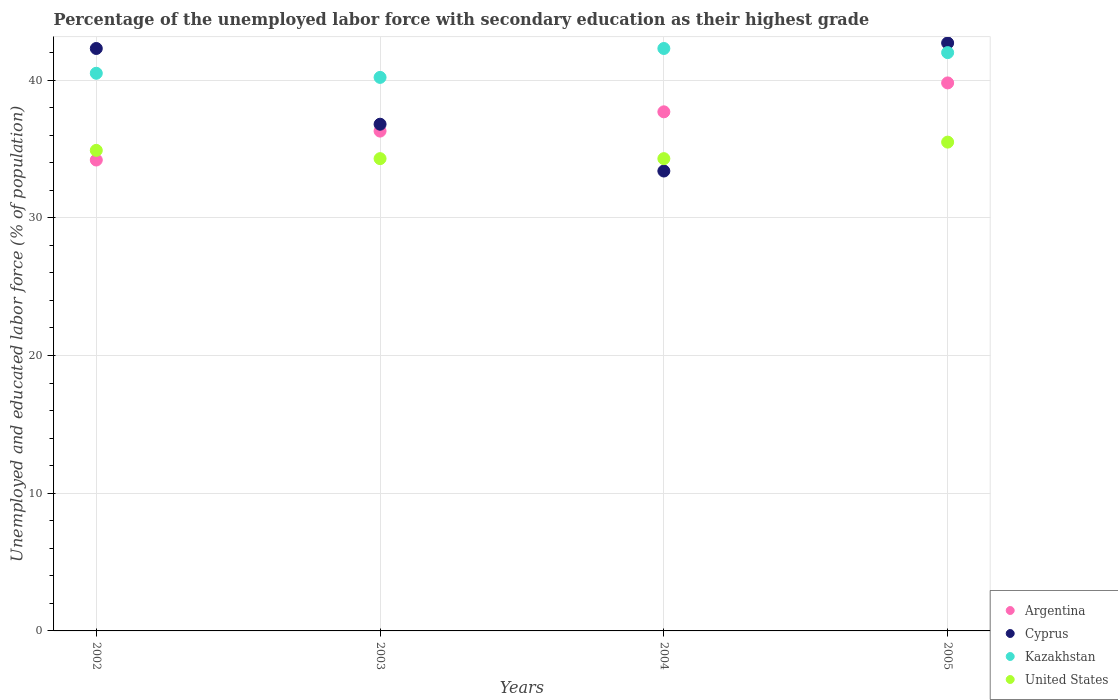Is the number of dotlines equal to the number of legend labels?
Give a very brief answer. Yes. Across all years, what is the maximum percentage of the unemployed labor force with secondary education in Cyprus?
Offer a very short reply. 42.7. Across all years, what is the minimum percentage of the unemployed labor force with secondary education in Kazakhstan?
Your response must be concise. 40.2. What is the total percentage of the unemployed labor force with secondary education in Cyprus in the graph?
Offer a terse response. 155.2. What is the difference between the percentage of the unemployed labor force with secondary education in Kazakhstan in 2003 and that in 2004?
Provide a short and direct response. -2.1. What is the average percentage of the unemployed labor force with secondary education in Cyprus per year?
Your answer should be compact. 38.8. In the year 2003, what is the difference between the percentage of the unemployed labor force with secondary education in Argentina and percentage of the unemployed labor force with secondary education in United States?
Give a very brief answer. 2. What is the ratio of the percentage of the unemployed labor force with secondary education in Kazakhstan in 2003 to that in 2005?
Provide a succinct answer. 0.96. Is the percentage of the unemployed labor force with secondary education in Cyprus in 2002 less than that in 2005?
Offer a very short reply. Yes. What is the difference between the highest and the second highest percentage of the unemployed labor force with secondary education in United States?
Provide a short and direct response. 0.6. What is the difference between the highest and the lowest percentage of the unemployed labor force with secondary education in Argentina?
Ensure brevity in your answer.  5.6. In how many years, is the percentage of the unemployed labor force with secondary education in Argentina greater than the average percentage of the unemployed labor force with secondary education in Argentina taken over all years?
Make the answer very short. 2. Is the percentage of the unemployed labor force with secondary education in Argentina strictly greater than the percentage of the unemployed labor force with secondary education in Kazakhstan over the years?
Your answer should be compact. No. How many dotlines are there?
Your answer should be compact. 4. How many years are there in the graph?
Give a very brief answer. 4. What is the difference between two consecutive major ticks on the Y-axis?
Give a very brief answer. 10. Does the graph contain any zero values?
Your response must be concise. No. What is the title of the graph?
Your answer should be compact. Percentage of the unemployed labor force with secondary education as their highest grade. Does "Fiji" appear as one of the legend labels in the graph?
Offer a terse response. No. What is the label or title of the Y-axis?
Make the answer very short. Unemployed and educated labor force (% of population). What is the Unemployed and educated labor force (% of population) of Argentina in 2002?
Your response must be concise. 34.2. What is the Unemployed and educated labor force (% of population) of Cyprus in 2002?
Provide a succinct answer. 42.3. What is the Unemployed and educated labor force (% of population) of Kazakhstan in 2002?
Offer a very short reply. 40.5. What is the Unemployed and educated labor force (% of population) of United States in 2002?
Offer a very short reply. 34.9. What is the Unemployed and educated labor force (% of population) of Argentina in 2003?
Your response must be concise. 36.3. What is the Unemployed and educated labor force (% of population) of Cyprus in 2003?
Offer a very short reply. 36.8. What is the Unemployed and educated labor force (% of population) of Kazakhstan in 2003?
Offer a terse response. 40.2. What is the Unemployed and educated labor force (% of population) of United States in 2003?
Keep it short and to the point. 34.3. What is the Unemployed and educated labor force (% of population) in Argentina in 2004?
Make the answer very short. 37.7. What is the Unemployed and educated labor force (% of population) of Cyprus in 2004?
Give a very brief answer. 33.4. What is the Unemployed and educated labor force (% of population) in Kazakhstan in 2004?
Give a very brief answer. 42.3. What is the Unemployed and educated labor force (% of population) in United States in 2004?
Provide a succinct answer. 34.3. What is the Unemployed and educated labor force (% of population) in Argentina in 2005?
Your answer should be compact. 39.8. What is the Unemployed and educated labor force (% of population) of Cyprus in 2005?
Offer a very short reply. 42.7. What is the Unemployed and educated labor force (% of population) in Kazakhstan in 2005?
Offer a terse response. 42. What is the Unemployed and educated labor force (% of population) in United States in 2005?
Your answer should be compact. 35.5. Across all years, what is the maximum Unemployed and educated labor force (% of population) of Argentina?
Give a very brief answer. 39.8. Across all years, what is the maximum Unemployed and educated labor force (% of population) in Cyprus?
Make the answer very short. 42.7. Across all years, what is the maximum Unemployed and educated labor force (% of population) of Kazakhstan?
Provide a short and direct response. 42.3. Across all years, what is the maximum Unemployed and educated labor force (% of population) of United States?
Make the answer very short. 35.5. Across all years, what is the minimum Unemployed and educated labor force (% of population) of Argentina?
Ensure brevity in your answer.  34.2. Across all years, what is the minimum Unemployed and educated labor force (% of population) of Cyprus?
Your response must be concise. 33.4. Across all years, what is the minimum Unemployed and educated labor force (% of population) of Kazakhstan?
Provide a succinct answer. 40.2. Across all years, what is the minimum Unemployed and educated labor force (% of population) of United States?
Keep it short and to the point. 34.3. What is the total Unemployed and educated labor force (% of population) of Argentina in the graph?
Offer a very short reply. 148. What is the total Unemployed and educated labor force (% of population) in Cyprus in the graph?
Your response must be concise. 155.2. What is the total Unemployed and educated labor force (% of population) of Kazakhstan in the graph?
Your answer should be compact. 165. What is the total Unemployed and educated labor force (% of population) in United States in the graph?
Keep it short and to the point. 139. What is the difference between the Unemployed and educated labor force (% of population) of Cyprus in 2002 and that in 2003?
Your answer should be compact. 5.5. What is the difference between the Unemployed and educated labor force (% of population) in Kazakhstan in 2002 and that in 2003?
Ensure brevity in your answer.  0.3. What is the difference between the Unemployed and educated labor force (% of population) of United States in 2002 and that in 2003?
Offer a very short reply. 0.6. What is the difference between the Unemployed and educated labor force (% of population) of Argentina in 2002 and that in 2004?
Give a very brief answer. -3.5. What is the difference between the Unemployed and educated labor force (% of population) in United States in 2002 and that in 2005?
Offer a very short reply. -0.6. What is the difference between the Unemployed and educated labor force (% of population) of Kazakhstan in 2003 and that in 2004?
Give a very brief answer. -2.1. What is the difference between the Unemployed and educated labor force (% of population) in United States in 2003 and that in 2004?
Your answer should be very brief. 0. What is the difference between the Unemployed and educated labor force (% of population) in United States in 2003 and that in 2005?
Keep it short and to the point. -1.2. What is the difference between the Unemployed and educated labor force (% of population) in Argentina in 2004 and that in 2005?
Your answer should be very brief. -2.1. What is the difference between the Unemployed and educated labor force (% of population) of Cyprus in 2004 and that in 2005?
Ensure brevity in your answer.  -9.3. What is the difference between the Unemployed and educated labor force (% of population) in Argentina in 2002 and the Unemployed and educated labor force (% of population) in United States in 2003?
Keep it short and to the point. -0.1. What is the difference between the Unemployed and educated labor force (% of population) in Cyprus in 2002 and the Unemployed and educated labor force (% of population) in Kazakhstan in 2003?
Offer a terse response. 2.1. What is the difference between the Unemployed and educated labor force (% of population) in Cyprus in 2002 and the Unemployed and educated labor force (% of population) in United States in 2003?
Offer a terse response. 8. What is the difference between the Unemployed and educated labor force (% of population) of Kazakhstan in 2002 and the Unemployed and educated labor force (% of population) of United States in 2003?
Provide a succinct answer. 6.2. What is the difference between the Unemployed and educated labor force (% of population) in Argentina in 2002 and the Unemployed and educated labor force (% of population) in Cyprus in 2004?
Provide a short and direct response. 0.8. What is the difference between the Unemployed and educated labor force (% of population) of Argentina in 2002 and the Unemployed and educated labor force (% of population) of Kazakhstan in 2004?
Keep it short and to the point. -8.1. What is the difference between the Unemployed and educated labor force (% of population) of Argentina in 2002 and the Unemployed and educated labor force (% of population) of United States in 2004?
Make the answer very short. -0.1. What is the difference between the Unemployed and educated labor force (% of population) of Kazakhstan in 2002 and the Unemployed and educated labor force (% of population) of United States in 2004?
Give a very brief answer. 6.2. What is the difference between the Unemployed and educated labor force (% of population) in Argentina in 2002 and the Unemployed and educated labor force (% of population) in Kazakhstan in 2005?
Give a very brief answer. -7.8. What is the difference between the Unemployed and educated labor force (% of population) in Cyprus in 2002 and the Unemployed and educated labor force (% of population) in Kazakhstan in 2005?
Offer a very short reply. 0.3. What is the difference between the Unemployed and educated labor force (% of population) in Cyprus in 2002 and the Unemployed and educated labor force (% of population) in United States in 2005?
Make the answer very short. 6.8. What is the difference between the Unemployed and educated labor force (% of population) of Kazakhstan in 2002 and the Unemployed and educated labor force (% of population) of United States in 2005?
Provide a short and direct response. 5. What is the difference between the Unemployed and educated labor force (% of population) of Cyprus in 2003 and the Unemployed and educated labor force (% of population) of Kazakhstan in 2004?
Your answer should be very brief. -5.5. What is the difference between the Unemployed and educated labor force (% of population) in Cyprus in 2003 and the Unemployed and educated labor force (% of population) in United States in 2004?
Ensure brevity in your answer.  2.5. What is the difference between the Unemployed and educated labor force (% of population) of Kazakhstan in 2003 and the Unemployed and educated labor force (% of population) of United States in 2004?
Offer a terse response. 5.9. What is the difference between the Unemployed and educated labor force (% of population) in Argentina in 2003 and the Unemployed and educated labor force (% of population) in Cyprus in 2005?
Keep it short and to the point. -6.4. What is the difference between the Unemployed and educated labor force (% of population) of Argentina in 2003 and the Unemployed and educated labor force (% of population) of United States in 2005?
Ensure brevity in your answer.  0.8. What is the difference between the Unemployed and educated labor force (% of population) in Cyprus in 2003 and the Unemployed and educated labor force (% of population) in Kazakhstan in 2005?
Your answer should be very brief. -5.2. What is the difference between the Unemployed and educated labor force (% of population) of Cyprus in 2003 and the Unemployed and educated labor force (% of population) of United States in 2005?
Provide a succinct answer. 1.3. What is the difference between the Unemployed and educated labor force (% of population) of Kazakhstan in 2003 and the Unemployed and educated labor force (% of population) of United States in 2005?
Provide a short and direct response. 4.7. What is the difference between the Unemployed and educated labor force (% of population) in Argentina in 2004 and the Unemployed and educated labor force (% of population) in Kazakhstan in 2005?
Offer a very short reply. -4.3. What is the difference between the Unemployed and educated labor force (% of population) in Argentina in 2004 and the Unemployed and educated labor force (% of population) in United States in 2005?
Provide a succinct answer. 2.2. What is the average Unemployed and educated labor force (% of population) in Argentina per year?
Offer a terse response. 37. What is the average Unemployed and educated labor force (% of population) in Cyprus per year?
Your response must be concise. 38.8. What is the average Unemployed and educated labor force (% of population) in Kazakhstan per year?
Provide a short and direct response. 41.25. What is the average Unemployed and educated labor force (% of population) of United States per year?
Your answer should be very brief. 34.75. In the year 2002, what is the difference between the Unemployed and educated labor force (% of population) in Argentina and Unemployed and educated labor force (% of population) in United States?
Your answer should be very brief. -0.7. In the year 2003, what is the difference between the Unemployed and educated labor force (% of population) of Argentina and Unemployed and educated labor force (% of population) of United States?
Provide a short and direct response. 2. In the year 2003, what is the difference between the Unemployed and educated labor force (% of population) of Cyprus and Unemployed and educated labor force (% of population) of United States?
Offer a terse response. 2.5. In the year 2004, what is the difference between the Unemployed and educated labor force (% of population) of Argentina and Unemployed and educated labor force (% of population) of Cyprus?
Keep it short and to the point. 4.3. In the year 2004, what is the difference between the Unemployed and educated labor force (% of population) of Argentina and Unemployed and educated labor force (% of population) of United States?
Ensure brevity in your answer.  3.4. In the year 2004, what is the difference between the Unemployed and educated labor force (% of population) in Cyprus and Unemployed and educated labor force (% of population) in Kazakhstan?
Keep it short and to the point. -8.9. In the year 2004, what is the difference between the Unemployed and educated labor force (% of population) in Cyprus and Unemployed and educated labor force (% of population) in United States?
Offer a very short reply. -0.9. In the year 2005, what is the difference between the Unemployed and educated labor force (% of population) of Argentina and Unemployed and educated labor force (% of population) of Kazakhstan?
Offer a terse response. -2.2. In the year 2005, what is the difference between the Unemployed and educated labor force (% of population) in Cyprus and Unemployed and educated labor force (% of population) in Kazakhstan?
Your answer should be compact. 0.7. In the year 2005, what is the difference between the Unemployed and educated labor force (% of population) of Cyprus and Unemployed and educated labor force (% of population) of United States?
Ensure brevity in your answer.  7.2. What is the ratio of the Unemployed and educated labor force (% of population) of Argentina in 2002 to that in 2003?
Your response must be concise. 0.94. What is the ratio of the Unemployed and educated labor force (% of population) in Cyprus in 2002 to that in 2003?
Make the answer very short. 1.15. What is the ratio of the Unemployed and educated labor force (% of population) of Kazakhstan in 2002 to that in 2003?
Your response must be concise. 1.01. What is the ratio of the Unemployed and educated labor force (% of population) in United States in 2002 to that in 2003?
Offer a terse response. 1.02. What is the ratio of the Unemployed and educated labor force (% of population) of Argentina in 2002 to that in 2004?
Give a very brief answer. 0.91. What is the ratio of the Unemployed and educated labor force (% of population) of Cyprus in 2002 to that in 2004?
Give a very brief answer. 1.27. What is the ratio of the Unemployed and educated labor force (% of population) of Kazakhstan in 2002 to that in 2004?
Provide a short and direct response. 0.96. What is the ratio of the Unemployed and educated labor force (% of population) of United States in 2002 to that in 2004?
Provide a succinct answer. 1.02. What is the ratio of the Unemployed and educated labor force (% of population) in Argentina in 2002 to that in 2005?
Your response must be concise. 0.86. What is the ratio of the Unemployed and educated labor force (% of population) in Cyprus in 2002 to that in 2005?
Provide a succinct answer. 0.99. What is the ratio of the Unemployed and educated labor force (% of population) in United States in 2002 to that in 2005?
Offer a very short reply. 0.98. What is the ratio of the Unemployed and educated labor force (% of population) of Argentina in 2003 to that in 2004?
Offer a terse response. 0.96. What is the ratio of the Unemployed and educated labor force (% of population) in Cyprus in 2003 to that in 2004?
Ensure brevity in your answer.  1.1. What is the ratio of the Unemployed and educated labor force (% of population) of Kazakhstan in 2003 to that in 2004?
Make the answer very short. 0.95. What is the ratio of the Unemployed and educated labor force (% of population) of Argentina in 2003 to that in 2005?
Keep it short and to the point. 0.91. What is the ratio of the Unemployed and educated labor force (% of population) in Cyprus in 2003 to that in 2005?
Make the answer very short. 0.86. What is the ratio of the Unemployed and educated labor force (% of population) of Kazakhstan in 2003 to that in 2005?
Offer a very short reply. 0.96. What is the ratio of the Unemployed and educated labor force (% of population) in United States in 2003 to that in 2005?
Your answer should be compact. 0.97. What is the ratio of the Unemployed and educated labor force (% of population) of Argentina in 2004 to that in 2005?
Provide a short and direct response. 0.95. What is the ratio of the Unemployed and educated labor force (% of population) in Cyprus in 2004 to that in 2005?
Your answer should be very brief. 0.78. What is the ratio of the Unemployed and educated labor force (% of population) in Kazakhstan in 2004 to that in 2005?
Provide a short and direct response. 1.01. What is the ratio of the Unemployed and educated labor force (% of population) of United States in 2004 to that in 2005?
Your answer should be very brief. 0.97. What is the difference between the highest and the second highest Unemployed and educated labor force (% of population) of United States?
Offer a terse response. 0.6. What is the difference between the highest and the lowest Unemployed and educated labor force (% of population) of Cyprus?
Your response must be concise. 9.3. 